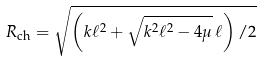<formula> <loc_0><loc_0><loc_500><loc_500>R _ { \text {ch} } = \sqrt { \left ( k \ell ^ { 2 } + \sqrt { k ^ { 2 } \ell ^ { 2 } - 4 \mu } \, \ell \right ) / 2 }</formula> 